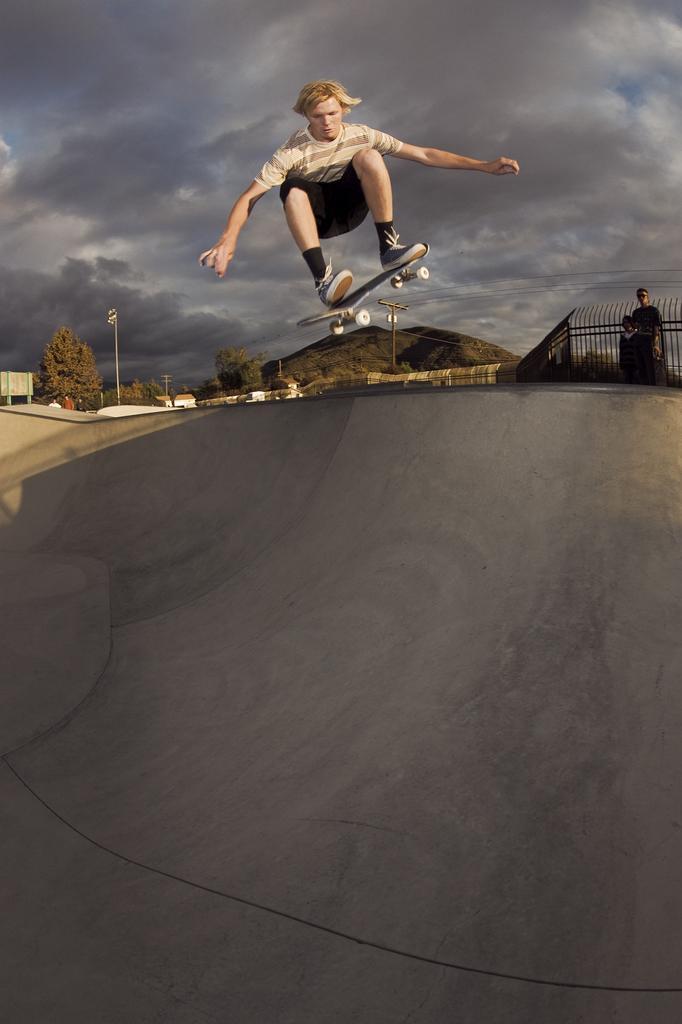Describe this image in one or two sentences. In the center of the image we can see a man jumping with skating board. At the bottom there is a ramp. In the background there are trees, hills, fence, poles and sky. On the right there are people standing. 